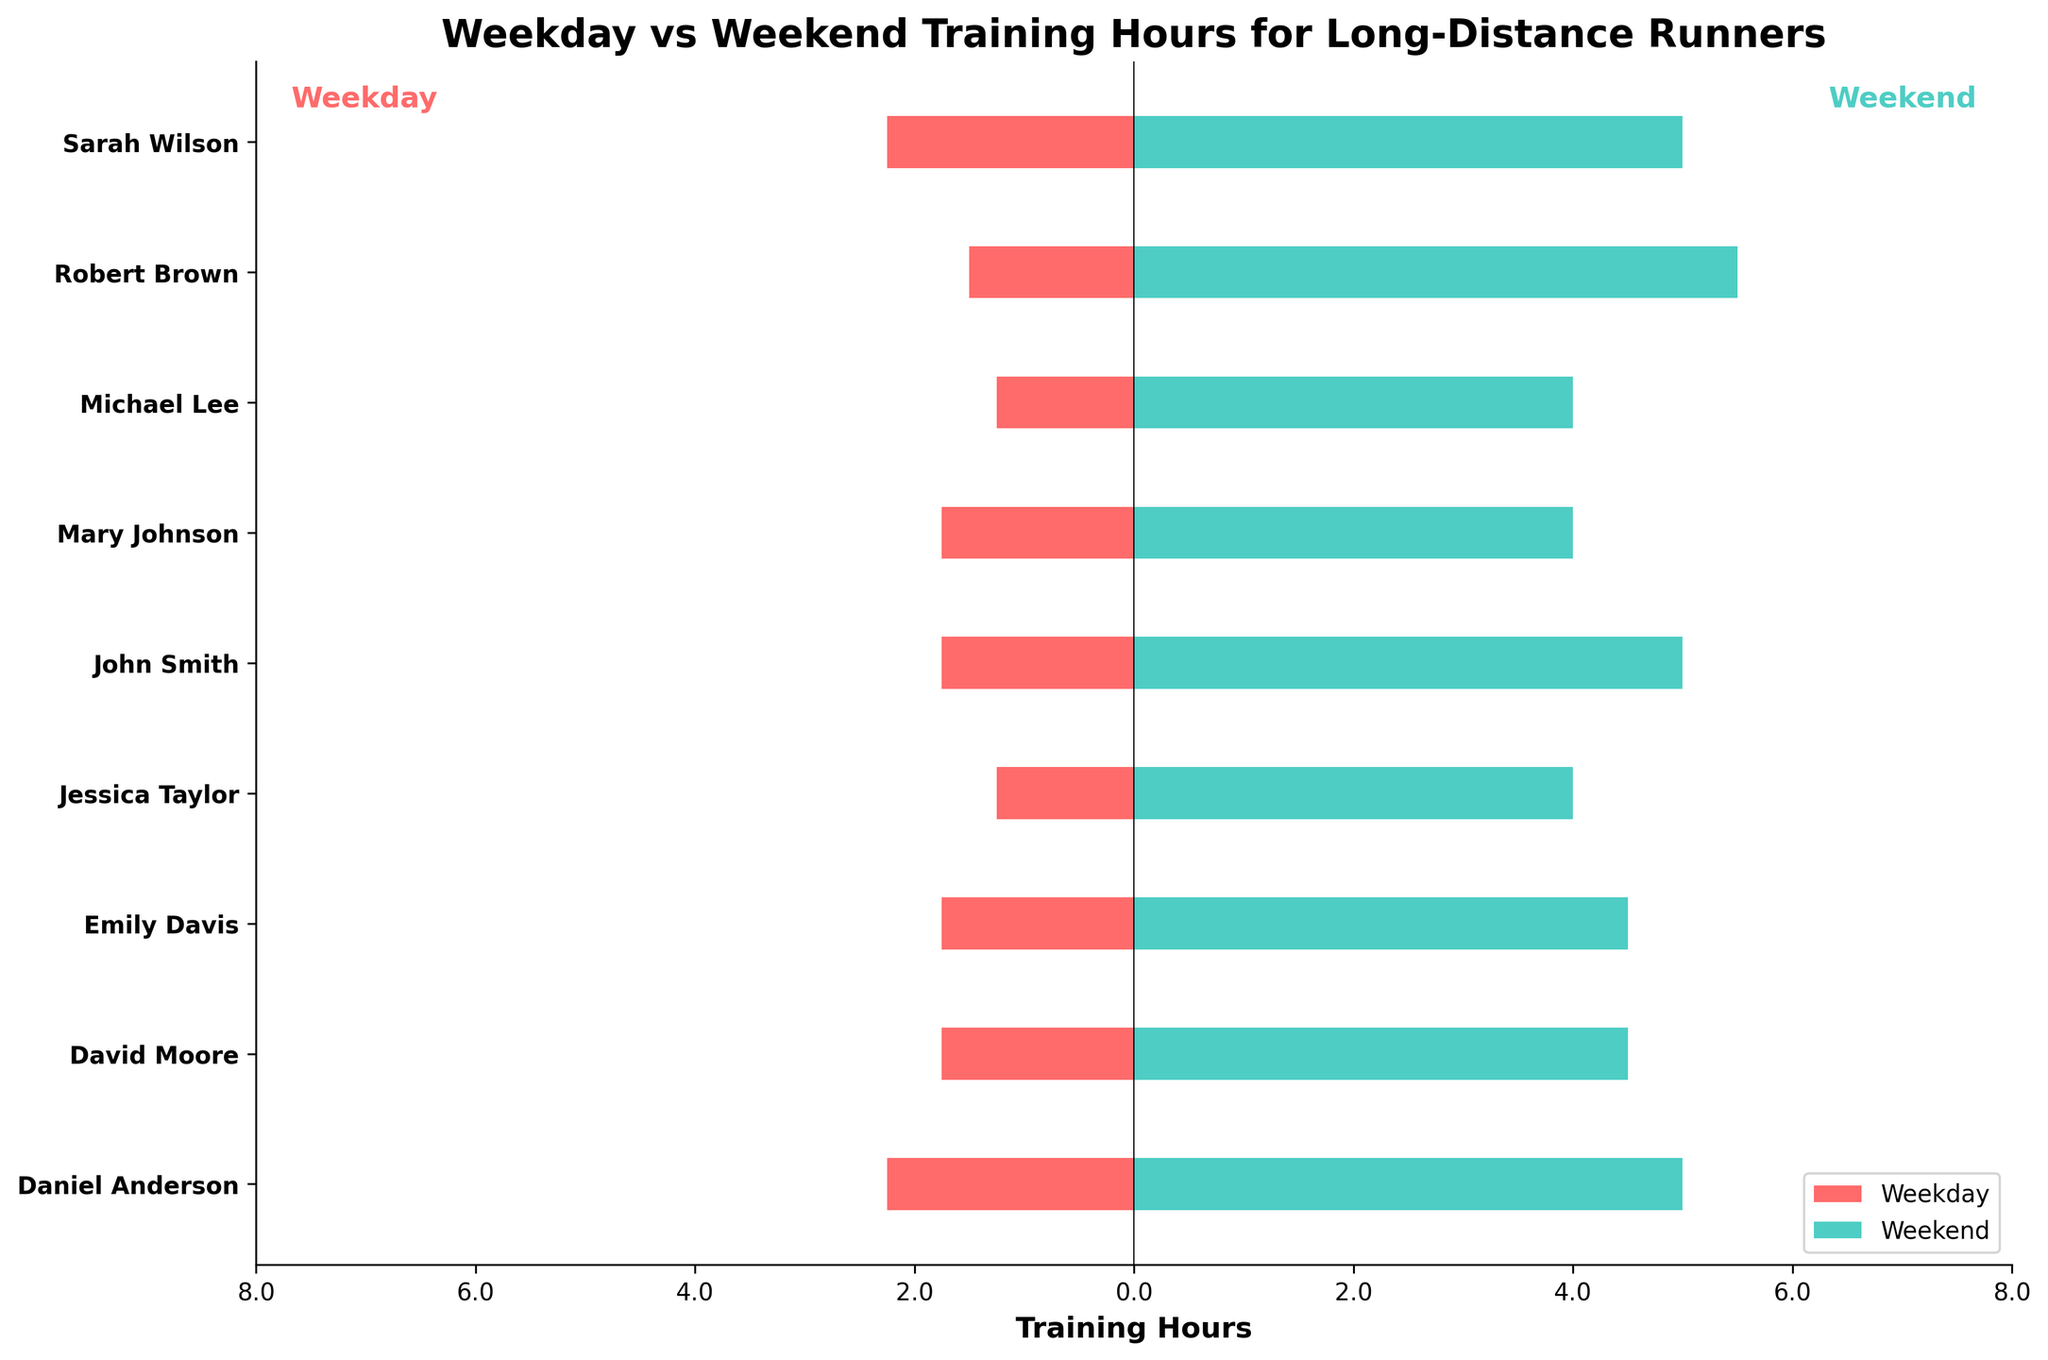Which runner trains the most on weekends? By looking at the weekend training hours for each runner, we identify that Robert Brown and Daniel Anderson have the highest training hours at 5.5 hours and 5 hours respectively. Comparatively, the others train less.
Answer: Robert Brown Which runner has the smallest difference between weekday and weekend training hours? Calculate the difference between weekend and average weekday training hours for each runner. Mary Johnson has a weekend training hour of 4, and her average weekday training is (1.5 + 2) / 2 = 1.75, so the difference is 4 - 1.75 = 2.25. John Smith has a difference of 5 - (2.5 + 1) / 2 = 3.25. Emily Davis has 4.5 - (2 + 1.5) / 2 = 2.25. Robert Brown has 5.5 - (1 + 2) / 2 = 4. Robert Brown ends up with the smallest difference of 2.25.
Answer: Emily Davis and Mary Johnson Which runner has the largest discrepancy in hours trained between weekdays and weekends? Calculate the discrepancy for each runner by subtracting the average weekday training hours from the weekend training hours and finding that Robert Brown has the largest difference: 5.5 (weekend) - 1.5 (average weekday) = 4 hours.
Answer: Robert Brown Does any runner train more during weekdays than weekends? Compare the average weekday training hours to the weekend training hours for each runner. All runners have higher weekend training hours compared to weekdays.
Answer: No Which runners train exactly 2 hours on average during weekdays? Identify the bars on the weekday side (represented in red) whose labels indicate an average of 2 training hours. John Smith, Sarah Wilson, and Daniel Anderson have labels showing exactly 2 training hours on weekdays.
Answer: John Smith, Sarah Wilson, and Daniel Anderson 